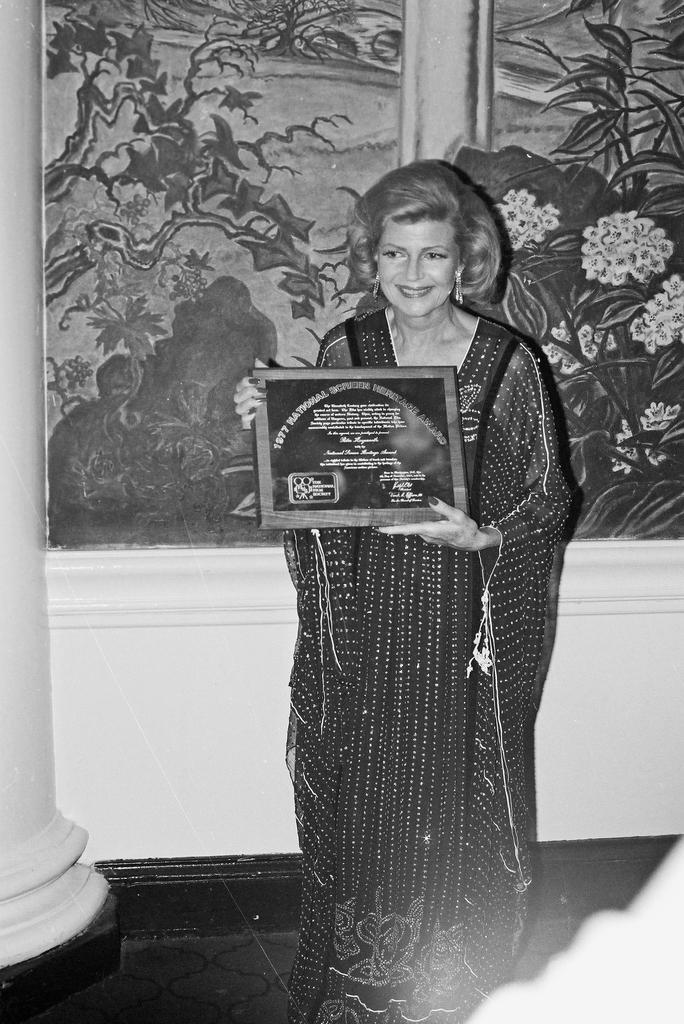Could you give a brief overview of what you see in this image? This is black and white image, in this image there is a woman holding an award in her hands, in the background there is a wall to that wall there is painting. 